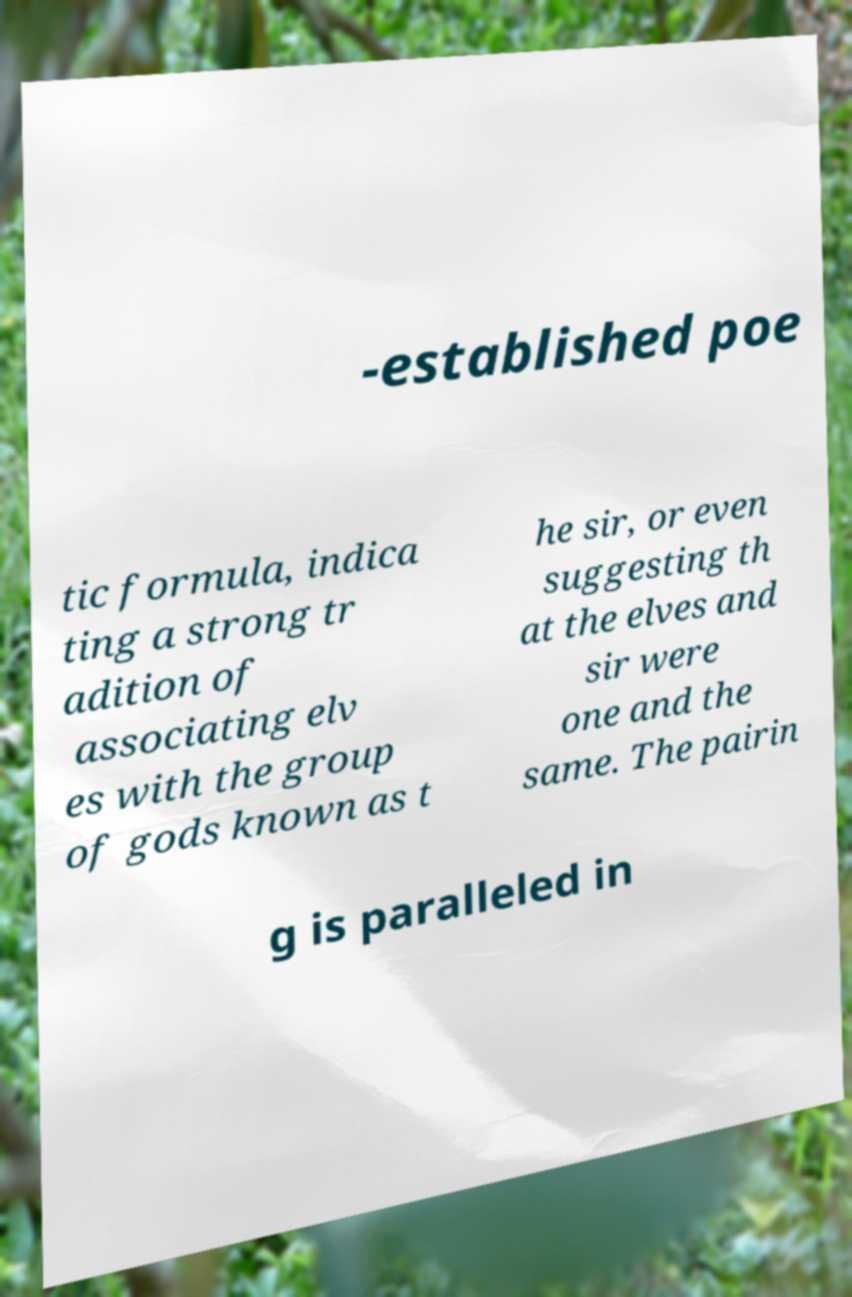There's text embedded in this image that I need extracted. Can you transcribe it verbatim? -established poe tic formula, indica ting a strong tr adition of associating elv es with the group of gods known as t he sir, or even suggesting th at the elves and sir were one and the same. The pairin g is paralleled in 